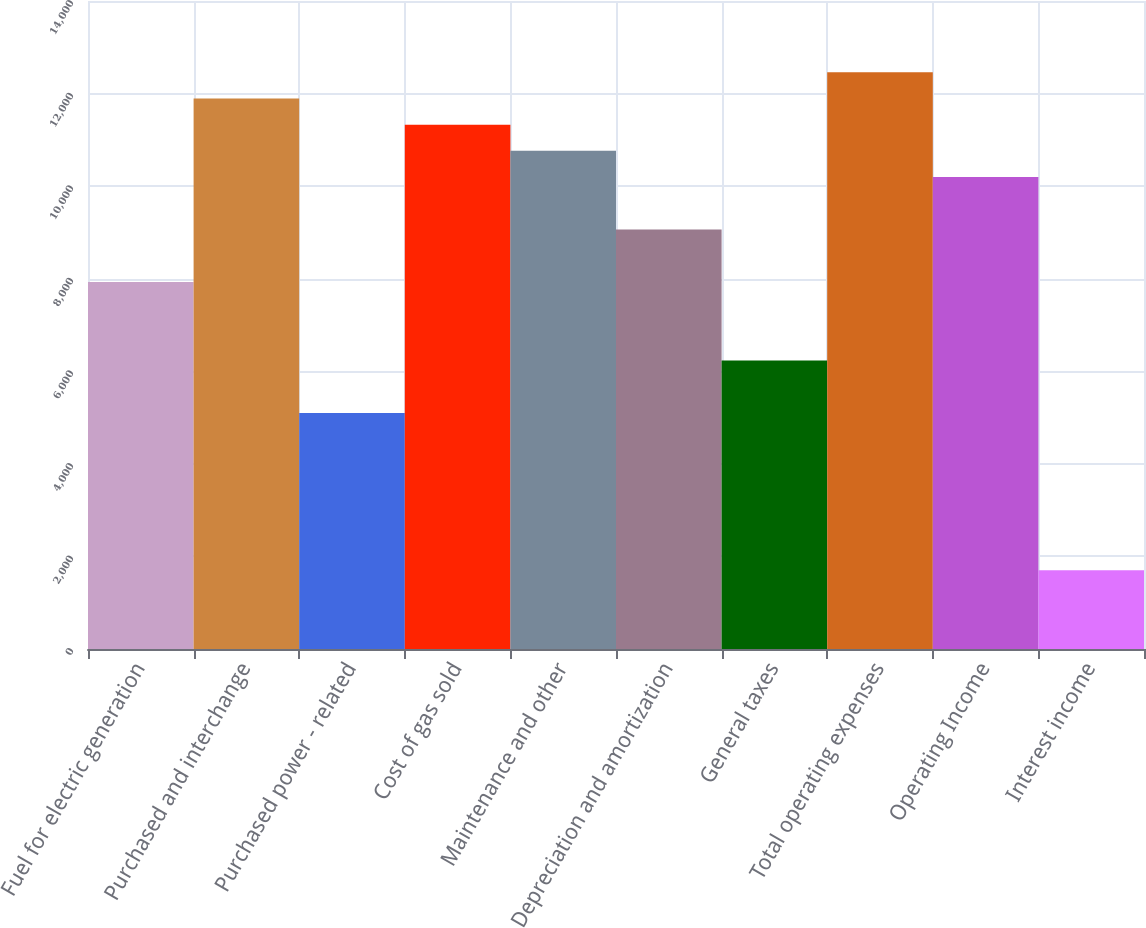Convert chart to OTSL. <chart><loc_0><loc_0><loc_500><loc_500><bar_chart><fcel>Fuel for electric generation<fcel>Purchased and interchange<fcel>Purchased power - related<fcel>Cost of gas sold<fcel>Maintenance and other<fcel>Depreciation and amortization<fcel>General taxes<fcel>Total operating expenses<fcel>Operating Income<fcel>Interest income<nl><fcel>7930.6<fcel>11895.4<fcel>5098.6<fcel>11329<fcel>10762.6<fcel>9063.4<fcel>6231.4<fcel>12461.8<fcel>10196.2<fcel>1700.2<nl></chart> 